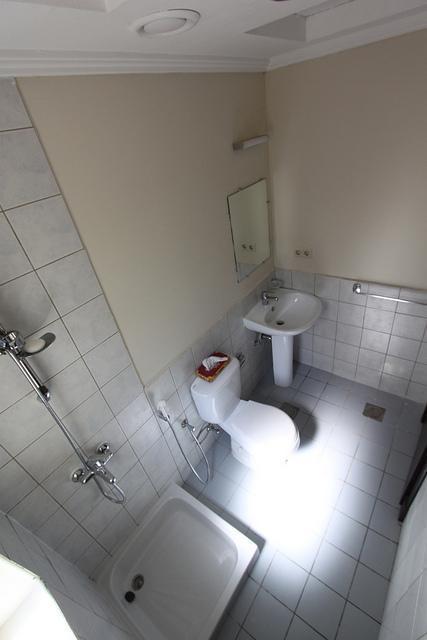How many sinks can you see?
Give a very brief answer. 2. 